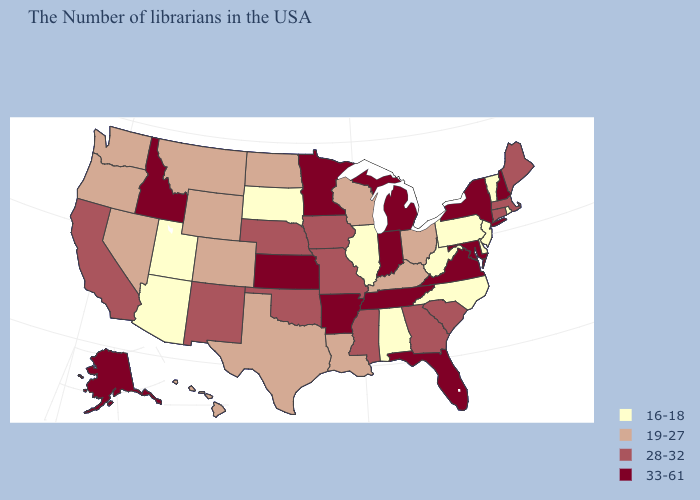Name the states that have a value in the range 28-32?
Write a very short answer. Maine, Massachusetts, Connecticut, South Carolina, Georgia, Mississippi, Missouri, Iowa, Nebraska, Oklahoma, New Mexico, California. What is the value of Alabama?
Quick response, please. 16-18. Among the states that border Mississippi , does Alabama have the lowest value?
Be succinct. Yes. Does Nebraska have the highest value in the USA?
Concise answer only. No. Does Illinois have the lowest value in the MidWest?
Concise answer only. Yes. Does the map have missing data?
Give a very brief answer. No. Name the states that have a value in the range 16-18?
Give a very brief answer. Rhode Island, Vermont, New Jersey, Delaware, Pennsylvania, North Carolina, West Virginia, Alabama, Illinois, South Dakota, Utah, Arizona. Does Minnesota have the highest value in the MidWest?
Write a very short answer. Yes. Which states have the lowest value in the MidWest?
Answer briefly. Illinois, South Dakota. What is the lowest value in states that border New Jersey?
Concise answer only. 16-18. Name the states that have a value in the range 16-18?
Short answer required. Rhode Island, Vermont, New Jersey, Delaware, Pennsylvania, North Carolina, West Virginia, Alabama, Illinois, South Dakota, Utah, Arizona. What is the value of Kentucky?
Be succinct. 19-27. Does New Hampshire have the highest value in the Northeast?
Short answer required. Yes. Which states have the lowest value in the MidWest?
Be succinct. Illinois, South Dakota. 